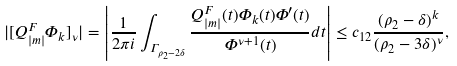<formula> <loc_0><loc_0><loc_500><loc_500>| [ Q _ { | m | } ^ { F } \Phi _ { k } ] _ { \nu } | = \left | \frac { 1 } { 2 \pi i } \int _ { \Gamma _ { \rho _ { 2 } - 2 \delta } } \frac { Q _ { | m | } ^ { F } ( t ) \Phi _ { k } ( t ) \Phi ^ { \prime } ( t ) } { \Phi ^ { \nu + 1 } ( t ) } d t \right | \leq c _ { 1 2 } \frac { ( \rho _ { 2 } - \delta ) ^ { k } } { ( \rho _ { 2 } - 3 \delta ) ^ { \nu } } ,</formula> 